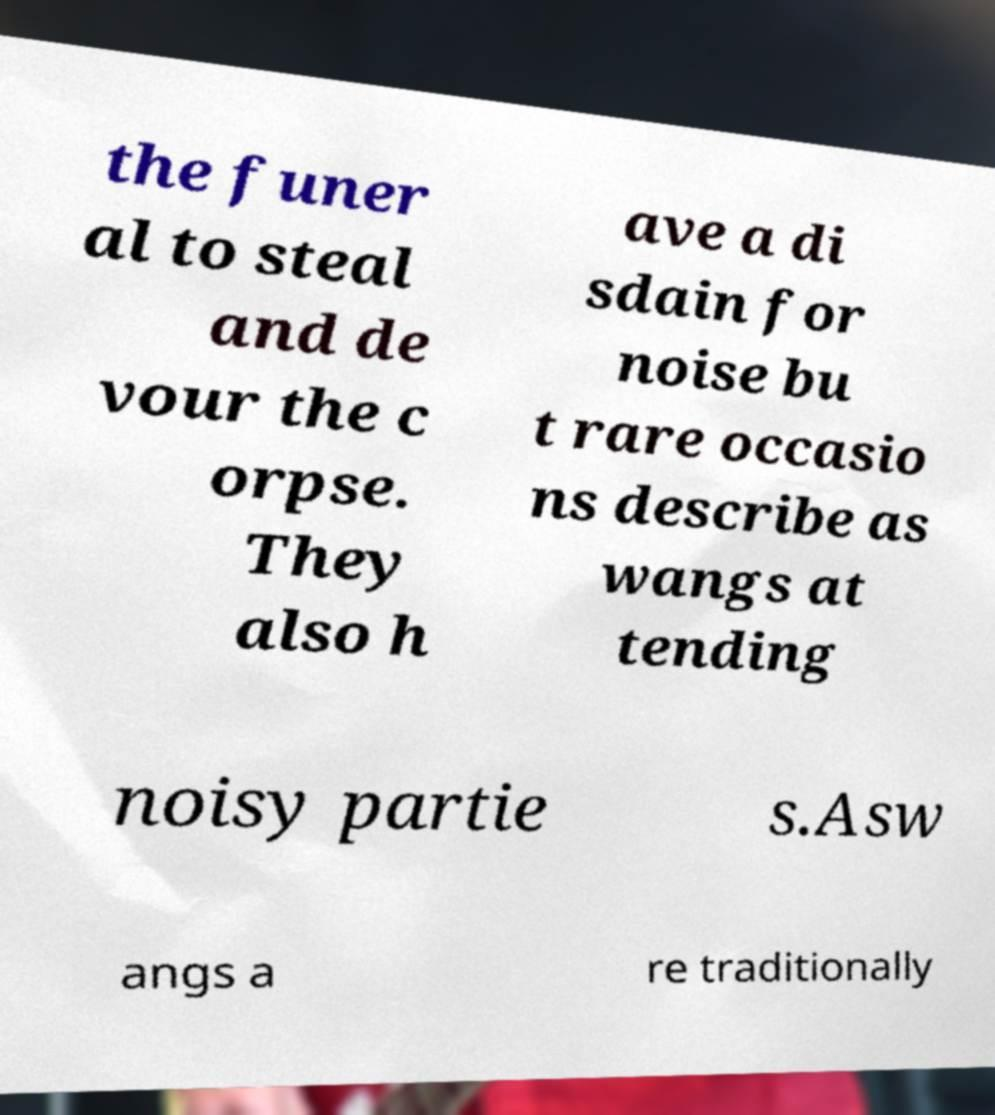Can you accurately transcribe the text from the provided image for me? the funer al to steal and de vour the c orpse. They also h ave a di sdain for noise bu t rare occasio ns describe as wangs at tending noisy partie s.Asw angs a re traditionally 